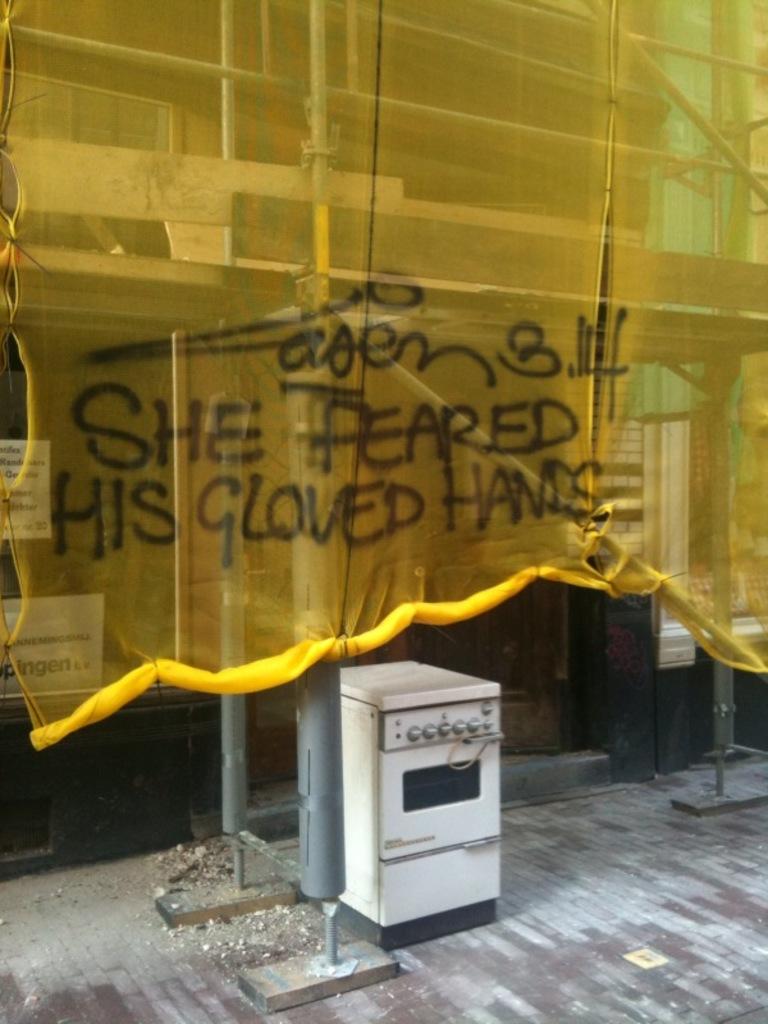What did she fear?
Provide a succinct answer. His gloved hands. Who feared gloved hands?
Your response must be concise. She. 